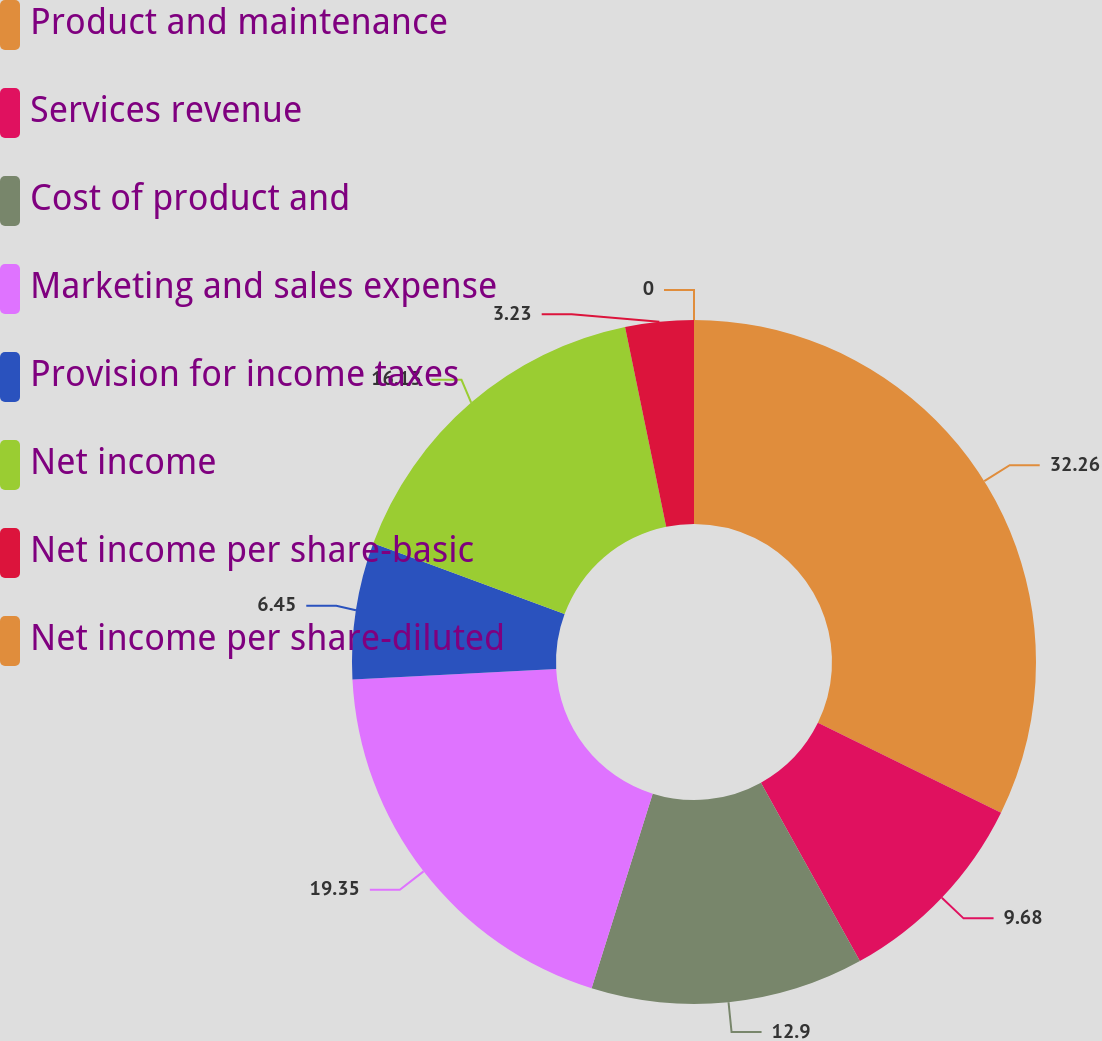Convert chart to OTSL. <chart><loc_0><loc_0><loc_500><loc_500><pie_chart><fcel>Product and maintenance<fcel>Services revenue<fcel>Cost of product and<fcel>Marketing and sales expense<fcel>Provision for income taxes<fcel>Net income<fcel>Net income per share-basic<fcel>Net income per share-diluted<nl><fcel>32.26%<fcel>9.68%<fcel>12.9%<fcel>19.35%<fcel>6.45%<fcel>16.13%<fcel>3.23%<fcel>0.0%<nl></chart> 